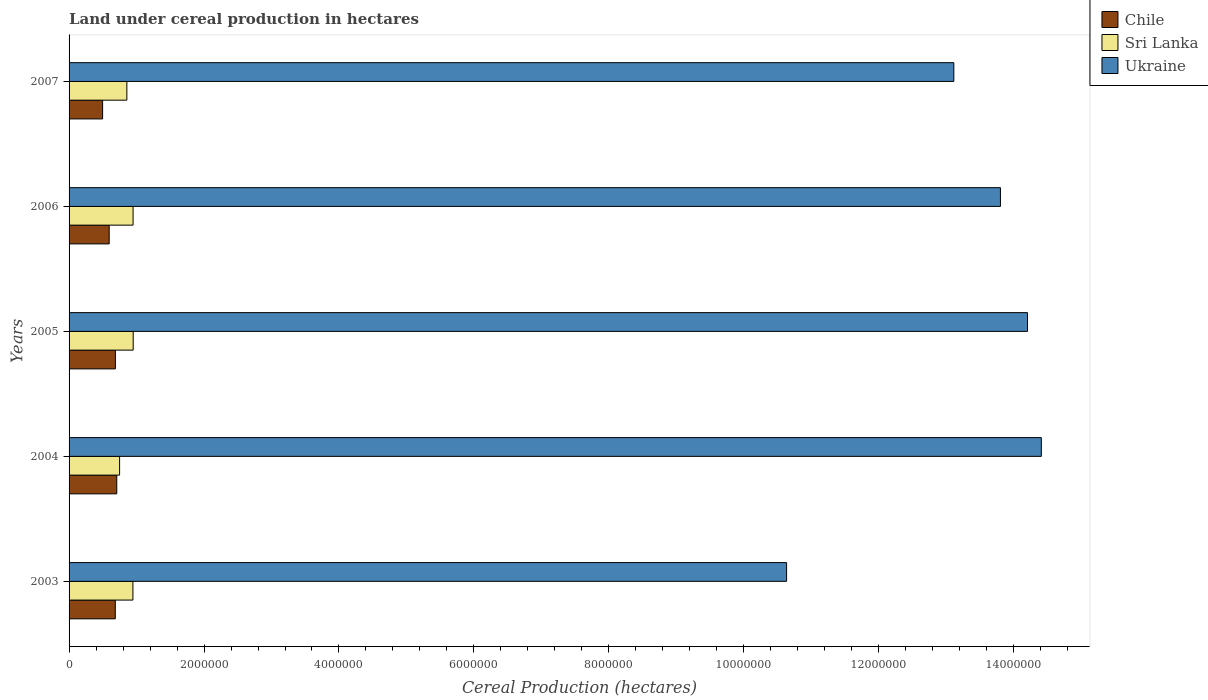Are the number of bars per tick equal to the number of legend labels?
Provide a short and direct response. Yes. How many bars are there on the 5th tick from the top?
Provide a succinct answer. 3. How many bars are there on the 5th tick from the bottom?
Your answer should be compact. 3. What is the label of the 4th group of bars from the top?
Ensure brevity in your answer.  2004. What is the land under cereal production in Sri Lanka in 2003?
Your response must be concise. 9.46e+05. Across all years, what is the maximum land under cereal production in Sri Lanka?
Make the answer very short. 9.50e+05. Across all years, what is the minimum land under cereal production in Ukraine?
Your response must be concise. 1.06e+07. In which year was the land under cereal production in Ukraine minimum?
Ensure brevity in your answer.  2003. What is the total land under cereal production in Ukraine in the graph?
Ensure brevity in your answer.  6.62e+07. What is the difference between the land under cereal production in Chile in 2003 and that in 2006?
Your answer should be compact. 9.07e+04. What is the difference between the land under cereal production in Chile in 2005 and the land under cereal production in Sri Lanka in 2007?
Give a very brief answer. -1.70e+05. What is the average land under cereal production in Chile per year?
Your answer should be compact. 6.34e+05. In the year 2007, what is the difference between the land under cereal production in Chile and land under cereal production in Ukraine?
Ensure brevity in your answer.  -1.26e+07. In how many years, is the land under cereal production in Sri Lanka greater than 8400000 hectares?
Provide a succinct answer. 0. What is the ratio of the land under cereal production in Ukraine in 2004 to that in 2007?
Your response must be concise. 1.1. What is the difference between the highest and the second highest land under cereal production in Chile?
Provide a short and direct response. 2.05e+04. What is the difference between the highest and the lowest land under cereal production in Sri Lanka?
Offer a terse response. 2.01e+05. What does the 2nd bar from the top in 2007 represents?
Give a very brief answer. Sri Lanka. Is it the case that in every year, the sum of the land under cereal production in Sri Lanka and land under cereal production in Ukraine is greater than the land under cereal production in Chile?
Ensure brevity in your answer.  Yes. How many bars are there?
Make the answer very short. 15. Are all the bars in the graph horizontal?
Your answer should be compact. Yes. What is the difference between two consecutive major ticks on the X-axis?
Your answer should be compact. 2.00e+06. Are the values on the major ticks of X-axis written in scientific E-notation?
Your answer should be compact. No. How many legend labels are there?
Keep it short and to the point. 3. How are the legend labels stacked?
Offer a very short reply. Vertical. What is the title of the graph?
Give a very brief answer. Land under cereal production in hectares. What is the label or title of the X-axis?
Your response must be concise. Cereal Production (hectares). What is the label or title of the Y-axis?
Offer a terse response. Years. What is the Cereal Production (hectares) in Chile in 2003?
Offer a very short reply. 6.85e+05. What is the Cereal Production (hectares) in Sri Lanka in 2003?
Your answer should be very brief. 9.46e+05. What is the Cereal Production (hectares) in Ukraine in 2003?
Your answer should be very brief. 1.06e+07. What is the Cereal Production (hectares) in Chile in 2004?
Make the answer very short. 7.07e+05. What is the Cereal Production (hectares) in Sri Lanka in 2004?
Provide a short and direct response. 7.49e+05. What is the Cereal Production (hectares) in Ukraine in 2004?
Provide a short and direct response. 1.44e+07. What is the Cereal Production (hectares) in Chile in 2005?
Your answer should be compact. 6.86e+05. What is the Cereal Production (hectares) of Sri Lanka in 2005?
Your answer should be compact. 9.50e+05. What is the Cereal Production (hectares) in Ukraine in 2005?
Provide a short and direct response. 1.42e+07. What is the Cereal Production (hectares) in Chile in 2006?
Your response must be concise. 5.94e+05. What is the Cereal Production (hectares) in Sri Lanka in 2006?
Provide a succinct answer. 9.49e+05. What is the Cereal Production (hectares) in Ukraine in 2006?
Provide a short and direct response. 1.38e+07. What is the Cereal Production (hectares) in Chile in 2007?
Your answer should be compact. 4.97e+05. What is the Cereal Production (hectares) in Sri Lanka in 2007?
Give a very brief answer. 8.57e+05. What is the Cereal Production (hectares) of Ukraine in 2007?
Give a very brief answer. 1.31e+07. Across all years, what is the maximum Cereal Production (hectares) in Chile?
Ensure brevity in your answer.  7.07e+05. Across all years, what is the maximum Cereal Production (hectares) of Sri Lanka?
Give a very brief answer. 9.50e+05. Across all years, what is the maximum Cereal Production (hectares) in Ukraine?
Make the answer very short. 1.44e+07. Across all years, what is the minimum Cereal Production (hectares) of Chile?
Your response must be concise. 4.97e+05. Across all years, what is the minimum Cereal Production (hectares) of Sri Lanka?
Provide a short and direct response. 7.49e+05. Across all years, what is the minimum Cereal Production (hectares) in Ukraine?
Ensure brevity in your answer.  1.06e+07. What is the total Cereal Production (hectares) of Chile in the graph?
Your response must be concise. 3.17e+06. What is the total Cereal Production (hectares) in Sri Lanka in the graph?
Give a very brief answer. 4.45e+06. What is the total Cereal Production (hectares) in Ukraine in the graph?
Keep it short and to the point. 6.62e+07. What is the difference between the Cereal Production (hectares) of Chile in 2003 and that in 2004?
Offer a terse response. -2.18e+04. What is the difference between the Cereal Production (hectares) in Sri Lanka in 2003 and that in 2004?
Provide a short and direct response. 1.98e+05. What is the difference between the Cereal Production (hectares) of Ukraine in 2003 and that in 2004?
Offer a very short reply. -3.78e+06. What is the difference between the Cereal Production (hectares) of Chile in 2003 and that in 2005?
Keep it short and to the point. -1318. What is the difference between the Cereal Production (hectares) of Sri Lanka in 2003 and that in 2005?
Ensure brevity in your answer.  -3860. What is the difference between the Cereal Production (hectares) of Ukraine in 2003 and that in 2005?
Your answer should be compact. -3.57e+06. What is the difference between the Cereal Production (hectares) in Chile in 2003 and that in 2006?
Offer a terse response. 9.07e+04. What is the difference between the Cereal Production (hectares) of Sri Lanka in 2003 and that in 2006?
Offer a terse response. -2323. What is the difference between the Cereal Production (hectares) in Ukraine in 2003 and that in 2006?
Make the answer very short. -3.17e+06. What is the difference between the Cereal Production (hectares) of Chile in 2003 and that in 2007?
Your answer should be compact. 1.88e+05. What is the difference between the Cereal Production (hectares) of Sri Lanka in 2003 and that in 2007?
Offer a terse response. 8.98e+04. What is the difference between the Cereal Production (hectares) of Ukraine in 2003 and that in 2007?
Make the answer very short. -2.48e+06. What is the difference between the Cereal Production (hectares) in Chile in 2004 and that in 2005?
Your answer should be compact. 2.05e+04. What is the difference between the Cereal Production (hectares) in Sri Lanka in 2004 and that in 2005?
Your answer should be compact. -2.01e+05. What is the difference between the Cereal Production (hectares) in Ukraine in 2004 and that in 2005?
Keep it short and to the point. 2.05e+05. What is the difference between the Cereal Production (hectares) of Chile in 2004 and that in 2006?
Offer a terse response. 1.12e+05. What is the difference between the Cereal Production (hectares) of Sri Lanka in 2004 and that in 2006?
Offer a terse response. -2.00e+05. What is the difference between the Cereal Production (hectares) of Ukraine in 2004 and that in 2006?
Your answer should be compact. 6.06e+05. What is the difference between the Cereal Production (hectares) of Chile in 2004 and that in 2007?
Ensure brevity in your answer.  2.10e+05. What is the difference between the Cereal Production (hectares) of Sri Lanka in 2004 and that in 2007?
Provide a succinct answer. -1.08e+05. What is the difference between the Cereal Production (hectares) of Ukraine in 2004 and that in 2007?
Provide a succinct answer. 1.30e+06. What is the difference between the Cereal Production (hectares) of Chile in 2005 and that in 2006?
Provide a succinct answer. 9.20e+04. What is the difference between the Cereal Production (hectares) in Sri Lanka in 2005 and that in 2006?
Offer a terse response. 1537. What is the difference between the Cereal Production (hectares) of Ukraine in 2005 and that in 2006?
Your answer should be very brief. 4.01e+05. What is the difference between the Cereal Production (hectares) in Chile in 2005 and that in 2007?
Make the answer very short. 1.89e+05. What is the difference between the Cereal Production (hectares) of Sri Lanka in 2005 and that in 2007?
Your answer should be very brief. 9.37e+04. What is the difference between the Cereal Production (hectares) of Ukraine in 2005 and that in 2007?
Give a very brief answer. 1.09e+06. What is the difference between the Cereal Production (hectares) in Chile in 2006 and that in 2007?
Your response must be concise. 9.74e+04. What is the difference between the Cereal Production (hectares) in Sri Lanka in 2006 and that in 2007?
Your response must be concise. 9.21e+04. What is the difference between the Cereal Production (hectares) in Ukraine in 2006 and that in 2007?
Make the answer very short. 6.91e+05. What is the difference between the Cereal Production (hectares) of Chile in 2003 and the Cereal Production (hectares) of Sri Lanka in 2004?
Ensure brevity in your answer.  -6.36e+04. What is the difference between the Cereal Production (hectares) in Chile in 2003 and the Cereal Production (hectares) in Ukraine in 2004?
Ensure brevity in your answer.  -1.37e+07. What is the difference between the Cereal Production (hectares) of Sri Lanka in 2003 and the Cereal Production (hectares) of Ukraine in 2004?
Keep it short and to the point. -1.35e+07. What is the difference between the Cereal Production (hectares) of Chile in 2003 and the Cereal Production (hectares) of Sri Lanka in 2005?
Your answer should be very brief. -2.65e+05. What is the difference between the Cereal Production (hectares) of Chile in 2003 and the Cereal Production (hectares) of Ukraine in 2005?
Provide a succinct answer. -1.35e+07. What is the difference between the Cereal Production (hectares) of Sri Lanka in 2003 and the Cereal Production (hectares) of Ukraine in 2005?
Your answer should be very brief. -1.33e+07. What is the difference between the Cereal Production (hectares) in Chile in 2003 and the Cereal Production (hectares) in Sri Lanka in 2006?
Keep it short and to the point. -2.64e+05. What is the difference between the Cereal Production (hectares) in Chile in 2003 and the Cereal Production (hectares) in Ukraine in 2006?
Provide a short and direct response. -1.31e+07. What is the difference between the Cereal Production (hectares) in Sri Lanka in 2003 and the Cereal Production (hectares) in Ukraine in 2006?
Ensure brevity in your answer.  -1.29e+07. What is the difference between the Cereal Production (hectares) of Chile in 2003 and the Cereal Production (hectares) of Sri Lanka in 2007?
Ensure brevity in your answer.  -1.71e+05. What is the difference between the Cereal Production (hectares) of Chile in 2003 and the Cereal Production (hectares) of Ukraine in 2007?
Your answer should be compact. -1.24e+07. What is the difference between the Cereal Production (hectares) in Sri Lanka in 2003 and the Cereal Production (hectares) in Ukraine in 2007?
Make the answer very short. -1.22e+07. What is the difference between the Cereal Production (hectares) in Chile in 2004 and the Cereal Production (hectares) in Sri Lanka in 2005?
Your answer should be compact. -2.43e+05. What is the difference between the Cereal Production (hectares) of Chile in 2004 and the Cereal Production (hectares) of Ukraine in 2005?
Offer a very short reply. -1.35e+07. What is the difference between the Cereal Production (hectares) in Sri Lanka in 2004 and the Cereal Production (hectares) in Ukraine in 2005?
Provide a short and direct response. -1.35e+07. What is the difference between the Cereal Production (hectares) of Chile in 2004 and the Cereal Production (hectares) of Sri Lanka in 2006?
Offer a very short reply. -2.42e+05. What is the difference between the Cereal Production (hectares) in Chile in 2004 and the Cereal Production (hectares) in Ukraine in 2006?
Offer a terse response. -1.31e+07. What is the difference between the Cereal Production (hectares) in Sri Lanka in 2004 and the Cereal Production (hectares) in Ukraine in 2006?
Offer a terse response. -1.31e+07. What is the difference between the Cereal Production (hectares) in Chile in 2004 and the Cereal Production (hectares) in Sri Lanka in 2007?
Give a very brief answer. -1.50e+05. What is the difference between the Cereal Production (hectares) in Chile in 2004 and the Cereal Production (hectares) in Ukraine in 2007?
Your answer should be compact. -1.24e+07. What is the difference between the Cereal Production (hectares) in Sri Lanka in 2004 and the Cereal Production (hectares) in Ukraine in 2007?
Provide a short and direct response. -1.24e+07. What is the difference between the Cereal Production (hectares) of Chile in 2005 and the Cereal Production (hectares) of Sri Lanka in 2006?
Ensure brevity in your answer.  -2.62e+05. What is the difference between the Cereal Production (hectares) of Chile in 2005 and the Cereal Production (hectares) of Ukraine in 2006?
Ensure brevity in your answer.  -1.31e+07. What is the difference between the Cereal Production (hectares) of Sri Lanka in 2005 and the Cereal Production (hectares) of Ukraine in 2006?
Offer a very short reply. -1.29e+07. What is the difference between the Cereal Production (hectares) of Chile in 2005 and the Cereal Production (hectares) of Sri Lanka in 2007?
Offer a very short reply. -1.70e+05. What is the difference between the Cereal Production (hectares) of Chile in 2005 and the Cereal Production (hectares) of Ukraine in 2007?
Keep it short and to the point. -1.24e+07. What is the difference between the Cereal Production (hectares) in Sri Lanka in 2005 and the Cereal Production (hectares) in Ukraine in 2007?
Ensure brevity in your answer.  -1.22e+07. What is the difference between the Cereal Production (hectares) of Chile in 2006 and the Cereal Production (hectares) of Sri Lanka in 2007?
Ensure brevity in your answer.  -2.62e+05. What is the difference between the Cereal Production (hectares) of Chile in 2006 and the Cereal Production (hectares) of Ukraine in 2007?
Make the answer very short. -1.25e+07. What is the difference between the Cereal Production (hectares) of Sri Lanka in 2006 and the Cereal Production (hectares) of Ukraine in 2007?
Give a very brief answer. -1.22e+07. What is the average Cereal Production (hectares) of Chile per year?
Make the answer very short. 6.34e+05. What is the average Cereal Production (hectares) in Sri Lanka per year?
Provide a succinct answer. 8.90e+05. What is the average Cereal Production (hectares) of Ukraine per year?
Your response must be concise. 1.32e+07. In the year 2003, what is the difference between the Cereal Production (hectares) of Chile and Cereal Production (hectares) of Sri Lanka?
Provide a succinct answer. -2.61e+05. In the year 2003, what is the difference between the Cereal Production (hectares) of Chile and Cereal Production (hectares) of Ukraine?
Provide a succinct answer. -9.95e+06. In the year 2003, what is the difference between the Cereal Production (hectares) in Sri Lanka and Cereal Production (hectares) in Ukraine?
Offer a very short reply. -9.69e+06. In the year 2004, what is the difference between the Cereal Production (hectares) in Chile and Cereal Production (hectares) in Sri Lanka?
Offer a terse response. -4.18e+04. In the year 2004, what is the difference between the Cereal Production (hectares) of Chile and Cereal Production (hectares) of Ukraine?
Provide a short and direct response. -1.37e+07. In the year 2004, what is the difference between the Cereal Production (hectares) in Sri Lanka and Cereal Production (hectares) in Ukraine?
Give a very brief answer. -1.37e+07. In the year 2005, what is the difference between the Cereal Production (hectares) of Chile and Cereal Production (hectares) of Sri Lanka?
Your answer should be very brief. -2.64e+05. In the year 2005, what is the difference between the Cereal Production (hectares) in Chile and Cereal Production (hectares) in Ukraine?
Provide a succinct answer. -1.35e+07. In the year 2005, what is the difference between the Cereal Production (hectares) of Sri Lanka and Cereal Production (hectares) of Ukraine?
Offer a very short reply. -1.33e+07. In the year 2006, what is the difference between the Cereal Production (hectares) of Chile and Cereal Production (hectares) of Sri Lanka?
Provide a succinct answer. -3.54e+05. In the year 2006, what is the difference between the Cereal Production (hectares) in Chile and Cereal Production (hectares) in Ukraine?
Offer a terse response. -1.32e+07. In the year 2006, what is the difference between the Cereal Production (hectares) in Sri Lanka and Cereal Production (hectares) in Ukraine?
Your answer should be very brief. -1.29e+07. In the year 2007, what is the difference between the Cereal Production (hectares) of Chile and Cereal Production (hectares) of Sri Lanka?
Provide a short and direct response. -3.59e+05. In the year 2007, what is the difference between the Cereal Production (hectares) of Chile and Cereal Production (hectares) of Ukraine?
Offer a terse response. -1.26e+07. In the year 2007, what is the difference between the Cereal Production (hectares) of Sri Lanka and Cereal Production (hectares) of Ukraine?
Keep it short and to the point. -1.23e+07. What is the ratio of the Cereal Production (hectares) in Chile in 2003 to that in 2004?
Ensure brevity in your answer.  0.97. What is the ratio of the Cereal Production (hectares) of Sri Lanka in 2003 to that in 2004?
Provide a short and direct response. 1.26. What is the ratio of the Cereal Production (hectares) of Ukraine in 2003 to that in 2004?
Your answer should be compact. 0.74. What is the ratio of the Cereal Production (hectares) in Sri Lanka in 2003 to that in 2005?
Offer a very short reply. 1. What is the ratio of the Cereal Production (hectares) in Ukraine in 2003 to that in 2005?
Your answer should be compact. 0.75. What is the ratio of the Cereal Production (hectares) in Chile in 2003 to that in 2006?
Your answer should be very brief. 1.15. What is the ratio of the Cereal Production (hectares) in Ukraine in 2003 to that in 2006?
Provide a succinct answer. 0.77. What is the ratio of the Cereal Production (hectares) in Chile in 2003 to that in 2007?
Ensure brevity in your answer.  1.38. What is the ratio of the Cereal Production (hectares) in Sri Lanka in 2003 to that in 2007?
Offer a very short reply. 1.1. What is the ratio of the Cereal Production (hectares) in Ukraine in 2003 to that in 2007?
Your response must be concise. 0.81. What is the ratio of the Cereal Production (hectares) of Chile in 2004 to that in 2005?
Provide a succinct answer. 1.03. What is the ratio of the Cereal Production (hectares) in Sri Lanka in 2004 to that in 2005?
Provide a short and direct response. 0.79. What is the ratio of the Cereal Production (hectares) of Ukraine in 2004 to that in 2005?
Give a very brief answer. 1.01. What is the ratio of the Cereal Production (hectares) of Chile in 2004 to that in 2006?
Provide a succinct answer. 1.19. What is the ratio of the Cereal Production (hectares) in Sri Lanka in 2004 to that in 2006?
Make the answer very short. 0.79. What is the ratio of the Cereal Production (hectares) in Ukraine in 2004 to that in 2006?
Ensure brevity in your answer.  1.04. What is the ratio of the Cereal Production (hectares) of Chile in 2004 to that in 2007?
Give a very brief answer. 1.42. What is the ratio of the Cereal Production (hectares) of Sri Lanka in 2004 to that in 2007?
Provide a short and direct response. 0.87. What is the ratio of the Cereal Production (hectares) of Ukraine in 2004 to that in 2007?
Provide a short and direct response. 1.1. What is the ratio of the Cereal Production (hectares) of Chile in 2005 to that in 2006?
Your response must be concise. 1.15. What is the ratio of the Cereal Production (hectares) in Ukraine in 2005 to that in 2006?
Your answer should be compact. 1.03. What is the ratio of the Cereal Production (hectares) in Chile in 2005 to that in 2007?
Ensure brevity in your answer.  1.38. What is the ratio of the Cereal Production (hectares) of Sri Lanka in 2005 to that in 2007?
Keep it short and to the point. 1.11. What is the ratio of the Cereal Production (hectares) of Chile in 2006 to that in 2007?
Offer a terse response. 1.2. What is the ratio of the Cereal Production (hectares) in Sri Lanka in 2006 to that in 2007?
Provide a succinct answer. 1.11. What is the ratio of the Cereal Production (hectares) in Ukraine in 2006 to that in 2007?
Your answer should be compact. 1.05. What is the difference between the highest and the second highest Cereal Production (hectares) in Chile?
Offer a terse response. 2.05e+04. What is the difference between the highest and the second highest Cereal Production (hectares) of Sri Lanka?
Keep it short and to the point. 1537. What is the difference between the highest and the second highest Cereal Production (hectares) of Ukraine?
Your answer should be compact. 2.05e+05. What is the difference between the highest and the lowest Cereal Production (hectares) in Chile?
Give a very brief answer. 2.10e+05. What is the difference between the highest and the lowest Cereal Production (hectares) of Sri Lanka?
Keep it short and to the point. 2.01e+05. What is the difference between the highest and the lowest Cereal Production (hectares) of Ukraine?
Your response must be concise. 3.78e+06. 